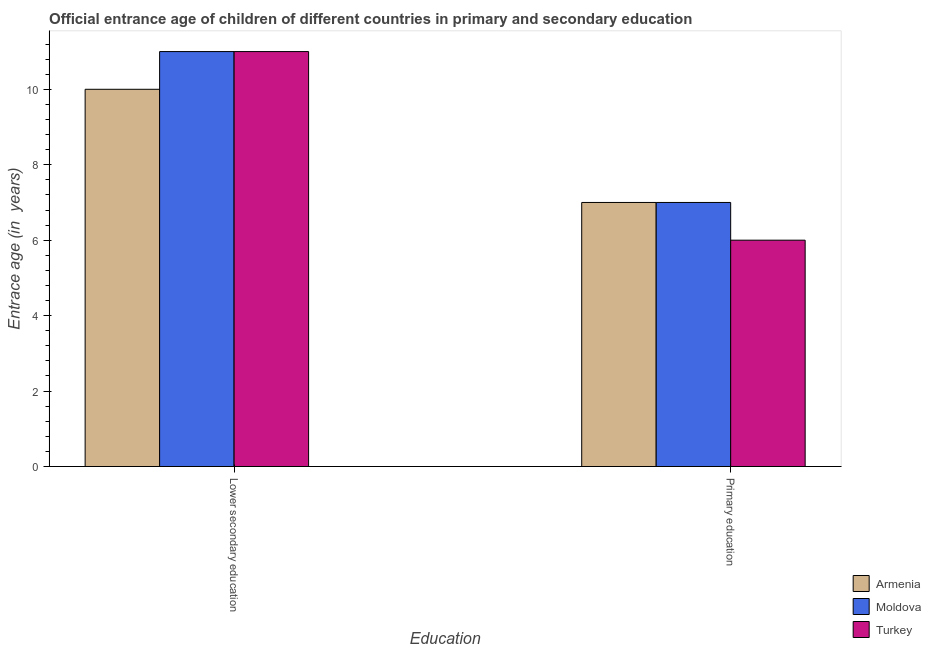Are the number of bars per tick equal to the number of legend labels?
Ensure brevity in your answer.  Yes. How many bars are there on the 1st tick from the left?
Your response must be concise. 3. What is the label of the 2nd group of bars from the left?
Provide a succinct answer. Primary education. What is the entrance age of children in lower secondary education in Armenia?
Your response must be concise. 10. Across all countries, what is the maximum entrance age of children in lower secondary education?
Provide a short and direct response. 11. Across all countries, what is the minimum entrance age of children in lower secondary education?
Provide a short and direct response. 10. In which country was the entrance age of chiildren in primary education maximum?
Give a very brief answer. Armenia. In which country was the entrance age of chiildren in primary education minimum?
Offer a terse response. Turkey. What is the total entrance age of chiildren in primary education in the graph?
Ensure brevity in your answer.  20. What is the difference between the entrance age of chiildren in primary education in Armenia and that in Moldova?
Offer a very short reply. 0. What is the difference between the entrance age of children in lower secondary education in Moldova and the entrance age of chiildren in primary education in Armenia?
Give a very brief answer. 4. What is the average entrance age of children in lower secondary education per country?
Ensure brevity in your answer.  10.67. What is the difference between the entrance age of chiildren in primary education and entrance age of children in lower secondary education in Moldova?
Keep it short and to the point. -4. What does the 3rd bar from the right in Lower secondary education represents?
Keep it short and to the point. Armenia. How many bars are there?
Keep it short and to the point. 6. Are all the bars in the graph horizontal?
Offer a very short reply. No. What is the difference between two consecutive major ticks on the Y-axis?
Provide a succinct answer. 2. Are the values on the major ticks of Y-axis written in scientific E-notation?
Offer a very short reply. No. How many legend labels are there?
Make the answer very short. 3. How are the legend labels stacked?
Your answer should be compact. Vertical. What is the title of the graph?
Offer a terse response. Official entrance age of children of different countries in primary and secondary education. What is the label or title of the X-axis?
Offer a very short reply. Education. What is the label or title of the Y-axis?
Your answer should be very brief. Entrace age (in  years). What is the Entrace age (in  years) in Moldova in Lower secondary education?
Provide a short and direct response. 11. What is the Entrace age (in  years) in Moldova in Primary education?
Your answer should be compact. 7. Across all Education, what is the minimum Entrace age (in  years) of Moldova?
Your answer should be very brief. 7. What is the total Entrace age (in  years) of Turkey in the graph?
Give a very brief answer. 17. What is the difference between the Entrace age (in  years) of Armenia in Lower secondary education and that in Primary education?
Offer a terse response. 3. What is the difference between the Entrace age (in  years) in Moldova in Lower secondary education and that in Primary education?
Your response must be concise. 4. What is the difference between the Entrace age (in  years) in Turkey in Lower secondary education and that in Primary education?
Offer a very short reply. 5. What is the average Entrace age (in  years) of Armenia per Education?
Provide a succinct answer. 8.5. What is the average Entrace age (in  years) in Moldova per Education?
Offer a very short reply. 9. What is the difference between the Entrace age (in  years) in Armenia and Entrace age (in  years) in Moldova in Lower secondary education?
Offer a very short reply. -1. What is the difference between the Entrace age (in  years) in Moldova and Entrace age (in  years) in Turkey in Lower secondary education?
Your answer should be very brief. 0. What is the difference between the Entrace age (in  years) of Moldova and Entrace age (in  years) of Turkey in Primary education?
Give a very brief answer. 1. What is the ratio of the Entrace age (in  years) of Armenia in Lower secondary education to that in Primary education?
Give a very brief answer. 1.43. What is the ratio of the Entrace age (in  years) of Moldova in Lower secondary education to that in Primary education?
Ensure brevity in your answer.  1.57. What is the ratio of the Entrace age (in  years) in Turkey in Lower secondary education to that in Primary education?
Your response must be concise. 1.83. What is the difference between the highest and the second highest Entrace age (in  years) of Armenia?
Keep it short and to the point. 3. What is the difference between the highest and the lowest Entrace age (in  years) of Moldova?
Your response must be concise. 4. What is the difference between the highest and the lowest Entrace age (in  years) of Turkey?
Your answer should be very brief. 5. 